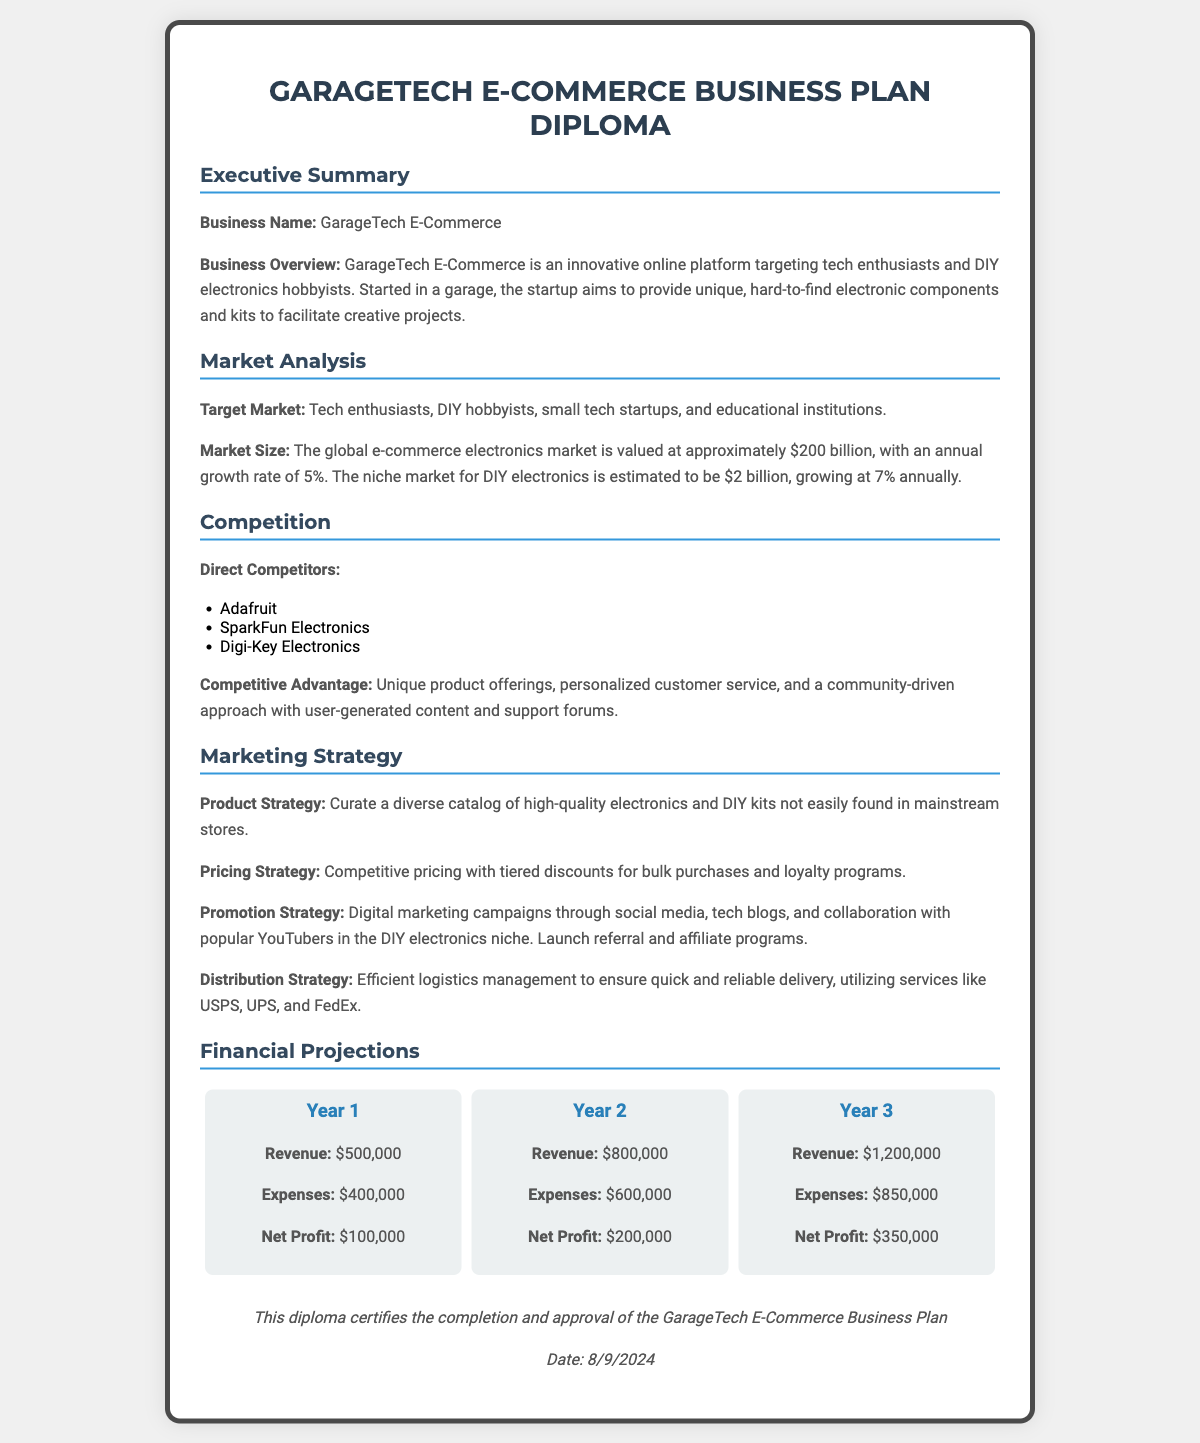What is the business name? The business name is mentioned in the executive summary section of the document as "GarageTech E-Commerce."
Answer: GarageTech E-Commerce What is the market size for DIY electronics? The document specifies that the niche market for DIY electronics is estimated to be $2 billion.
Answer: $2 billion Who are the direct competitors? Direct competitors are listed in the competition section, which includes multiple companies.
Answer: Adafruit, SparkFun Electronics, Digi-Key Electronics What is the revenue projected for Year 2? The financial projections indicate a revenue of $800,000 for Year 2.
Answer: $800,000 What is the competitive advantage mentioned? The document explains that the competitive advantage involves unique product offerings and personalized customer service.
Answer: Unique product offerings, personalized customer service What is the expected net profit in Year 3? According to the financial projections, the net profit for Year 3 is specified.
Answer: $350,000 What date is mentioned for the diploma? The document renders the date dynamically using script and does not specify a fixed date.
Answer: Current date What is the primary target market? The document indicates the primary target market includes tech enthusiasts and DIY hobbyists.
Answer: Tech enthusiasts, DIY hobbyists What is the promotion strategy? The marketing strategy section outlines the promotion strategy through digital marketing campaigns and collaboration with influencers.
Answer: Digital marketing campaigns, tech blogs, collaboration with popular YouTubers 